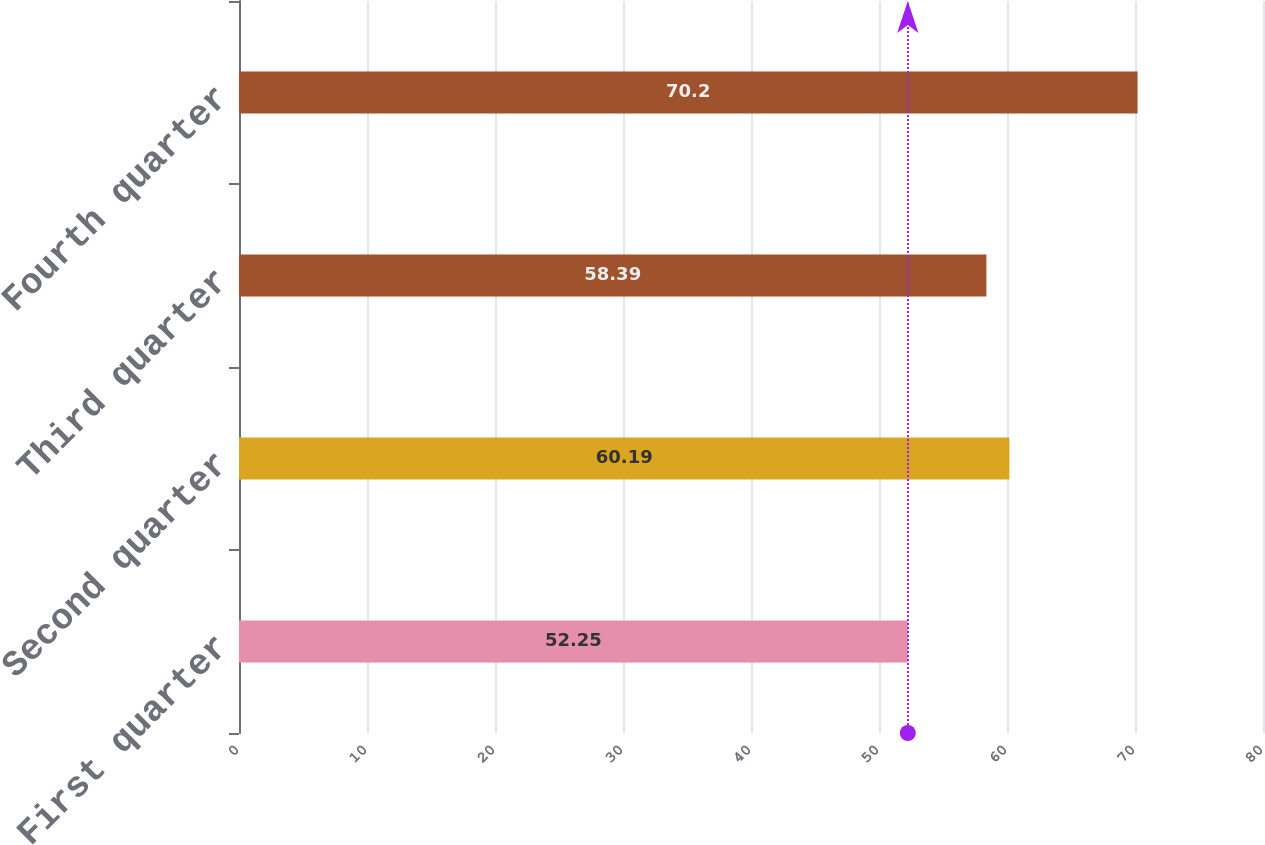Convert chart. <chart><loc_0><loc_0><loc_500><loc_500><bar_chart><fcel>First quarter<fcel>Second quarter<fcel>Third quarter<fcel>Fourth quarter<nl><fcel>52.25<fcel>60.19<fcel>58.39<fcel>70.2<nl></chart> 